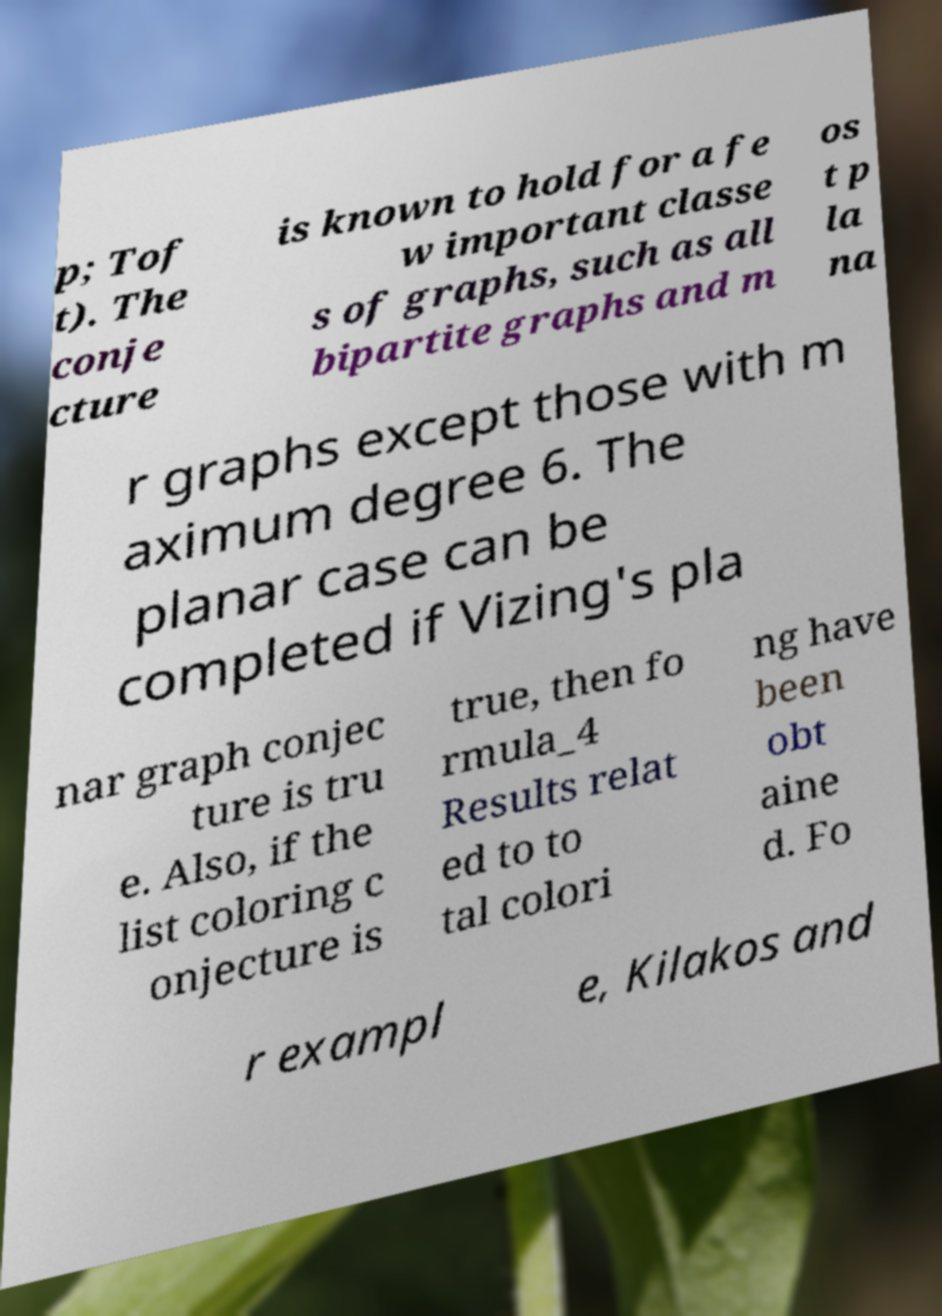What messages or text are displayed in this image? I need them in a readable, typed format. p; Tof t). The conje cture is known to hold for a fe w important classe s of graphs, such as all bipartite graphs and m os t p la na r graphs except those with m aximum degree 6. The planar case can be completed if Vizing's pla nar graph conjec ture is tru e. Also, if the list coloring c onjecture is true, then fo rmula_4 Results relat ed to to tal colori ng have been obt aine d. Fo r exampl e, Kilakos and 